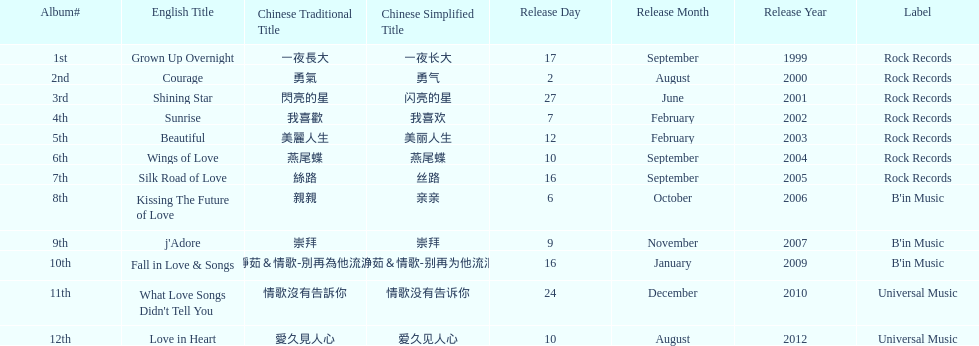Was the album beautiful released before the album love in heart? Yes. 